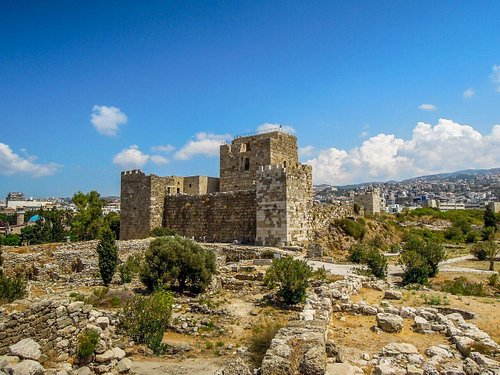Can you tell me more about the history of the structure in the foreground? Certainly! The structure in the foreground is a part of the extensive archaeological site in Byblos. It includes remnants of the Crusader castle built in the 12th century atop earlier Phoenician fortifications. This site has layers of history from different eras, including Greek, Roman, and Ottoman, which illustrate the strategic and commercial importance of Byblos through millennia. 